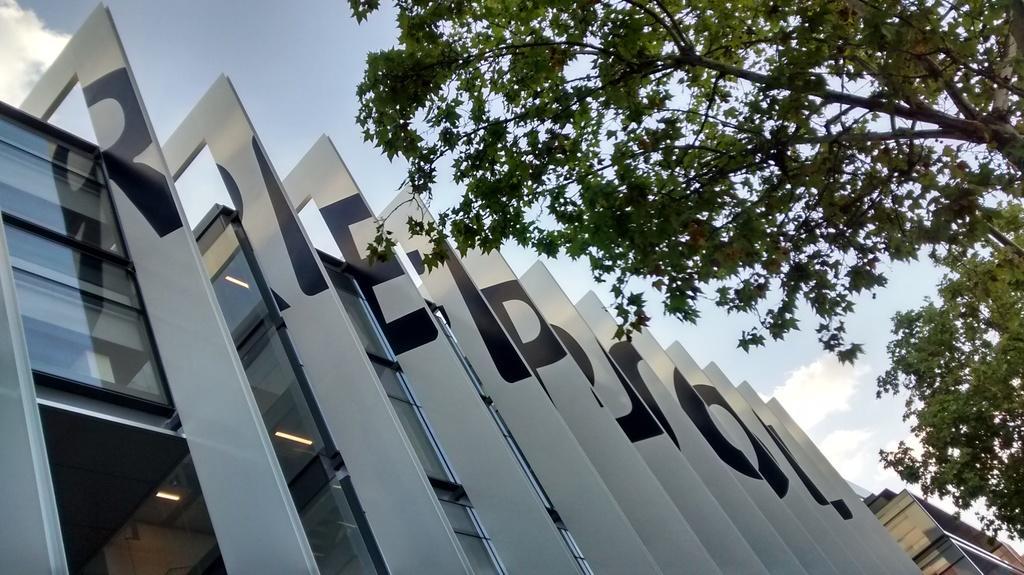Could you give a brief overview of what you see in this image? In this image we can see the architecture of the buildings. We can see the trees. At the top we can see the sky. 